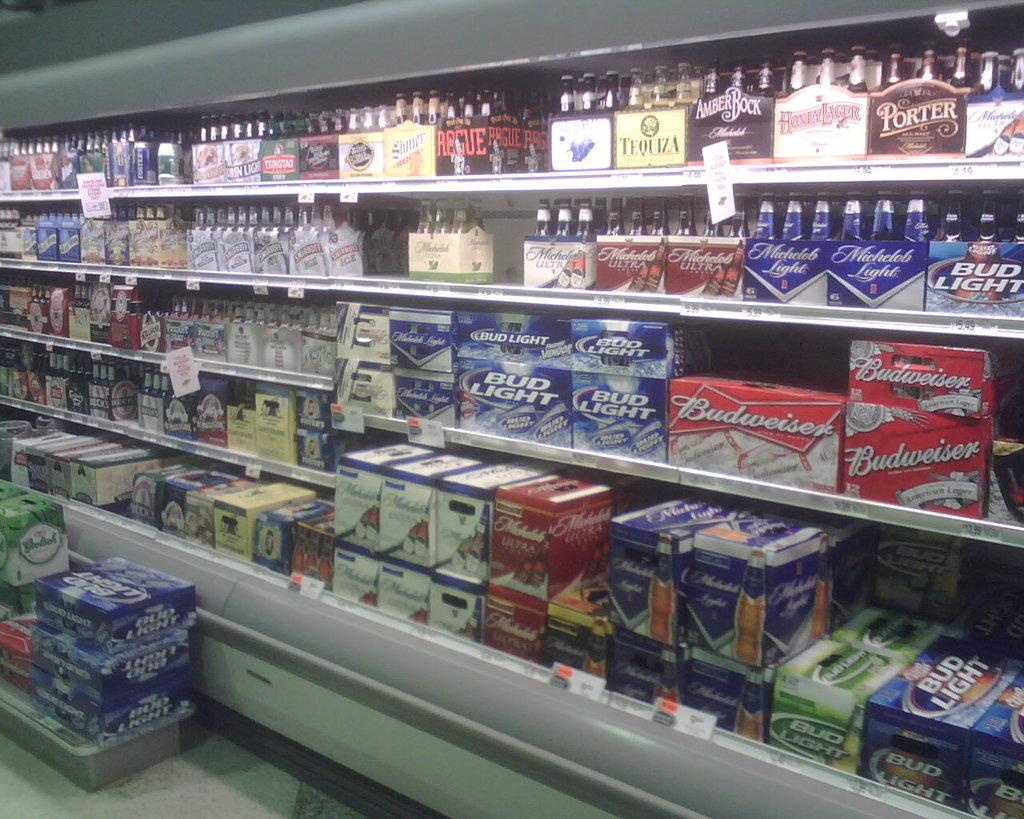Where was the image taken? The image was taken in a store. What can be seen in the center of the image? There are beverages in the center of the image. How are the beverages arranged in the image? The beverages are placed in racks. What else can be seen in the racks besides the beverages? There are cartons placed in the racks. What is located at the bottom of the image? There are boxes at the bottom of the image. What type of light fixture can be seen hanging from the ceiling in the image? There is no light fixture visible in the image. 